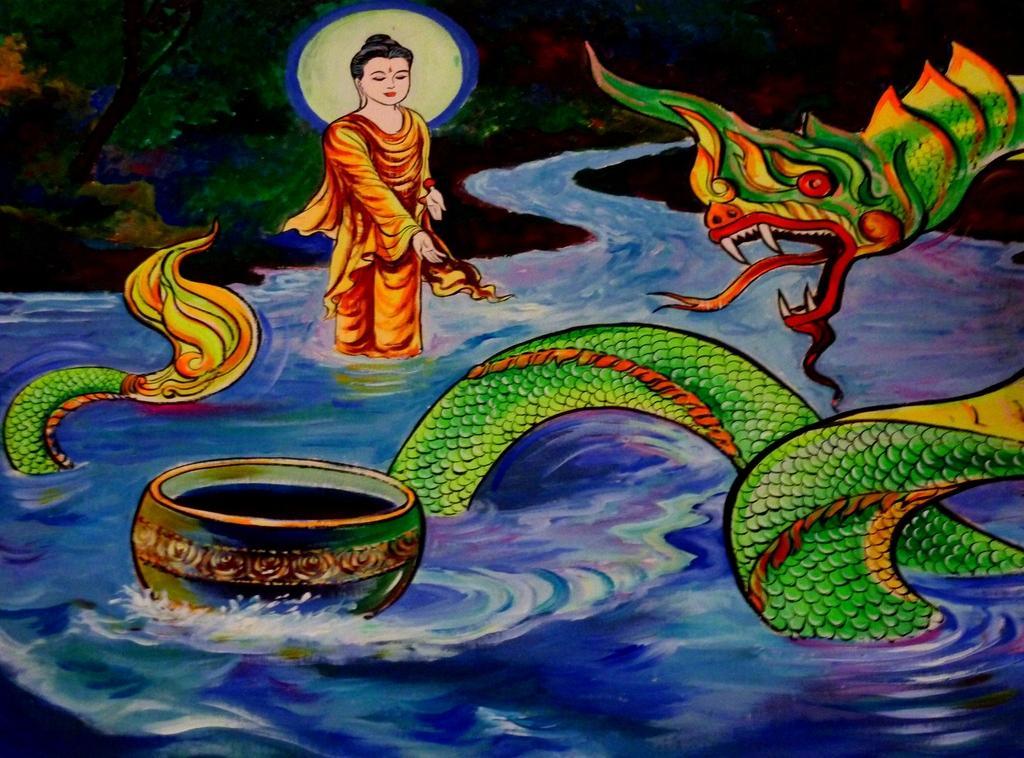How would you summarize this image in a sentence or two? Here we can see a painting, in this picture we can see a person, water, trees and a snake. 